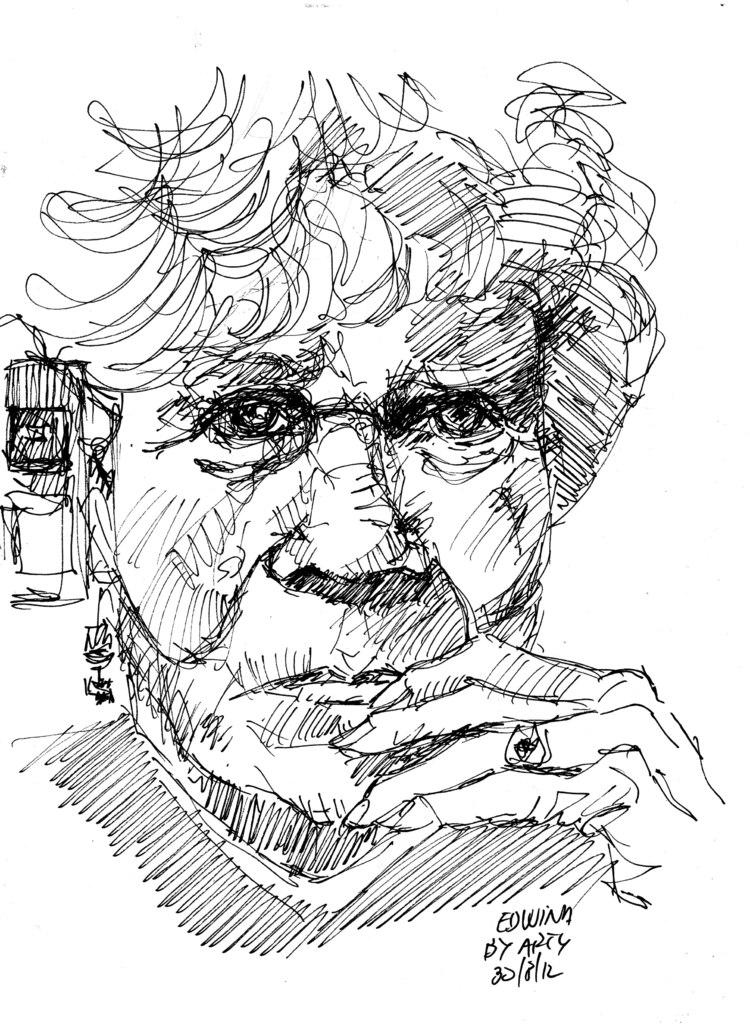What is the main subject of the image? The main subject of the image is a fart. Are there any people in the image? Yes, there is a woman in the image. Is there any text present in the image? Yes, there is text at the bottom right corner of the image. How many quartz crystals are present in the image? There is no mention of quartz crystals in the image, so it is not possible to determine their number. 